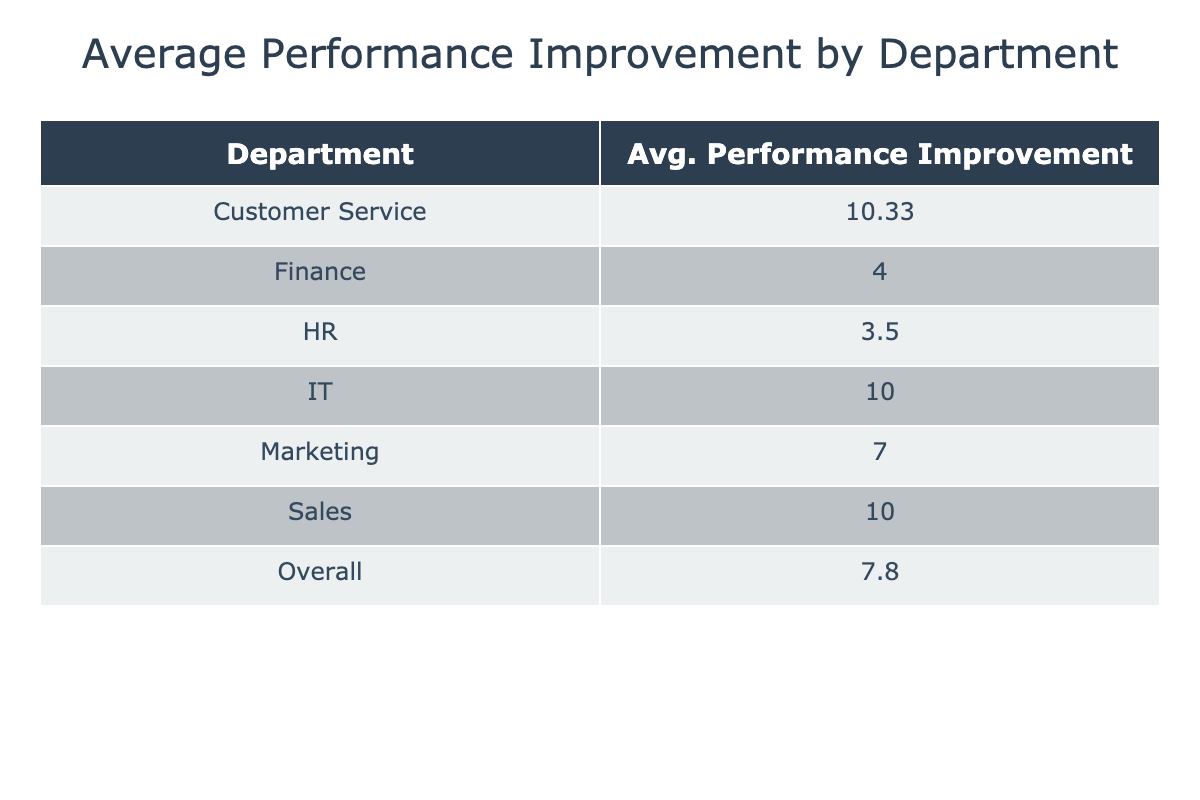What is the average performance improvement in the Sales department? The table indicates the performance improvement scores for the Sales department as 10, 8, and 12. To find the average, we sum these values: 10 + 8 + 12 = 30. There are three scores, so we divide by 3: 30 / 3 = 10.
Answer: 10 Which department had the highest average performance improvement? From the table, we can see the average performance improvements for each department: Sales (10), Marketing (7), Customer Service (9), IT (10), Finance (4), and HR (4). The departments with the highest average improvement are Sales and IT, both at 10.
Answer: Sales and IT Is the overall average performance improvement greater than 8? The overall average performance improvement, calculated from the table, is the sum of all performance improvements (10 + 8 + 10 + 10 + 4 + 4 + 8 + 8 + 9 + 10 + 4 + 3 + 12 + 5 + 12) equals 10. The total number of improvements is 15, so 10 / 15 = 6.67, which is less than 8.
Answer: No What is the performance improvement difference between the Customer Service and Finance departments? The average performance improvement for the Customer Service department is 9 (from three scores: 10, 9, and 12) and for Finance is 4 (from two scores: 4 and 4). The difference is 9 - 4 = 5.
Answer: 5 Is the average performance improvement for the IT department less than that of the Marketing department? The average performance improvement for the IT department is 10 while for the Marketing department it is 7. Since 10 is greater than 7, this statement is false.
Answer: No What is the total performance improvement for all employees in the month of May? The performance improvements for May are 12 (Sales), 5 (Marketing), and 12 (Customer Service). Adding these values gives us 12 + 5 + 12 = 29, which is the total improvement for May.
Answer: 29 How many employees showed an overall performance improvement of 10 or more? Looking at the entire dataset provided, the overall performance improvements of 10 or more are found in the scores of 10 (Sales, Customer Service, IT, Sales, Customer Service) and 12 (Sales, Customer Service) which gives us a total of 6 instances across all data points.
Answer: 6 What is the average performance score increase across both pre-training and post-training scores? To calculate the average score increase, we first need to compute the total performance score increase across all employees. This is done by taking the differentials of Pre-Training and Post-Training scores for each employee, then sum those increases and divide by the number of employees (15), resulting in an average increase of (10 + 8 + 10 + 10 + 4 + 4 + 8 + 8 + 9 + 10 + 4 + 3 + 12 + 5 + 12) / 15 = 6.67.
Answer: 6.67 